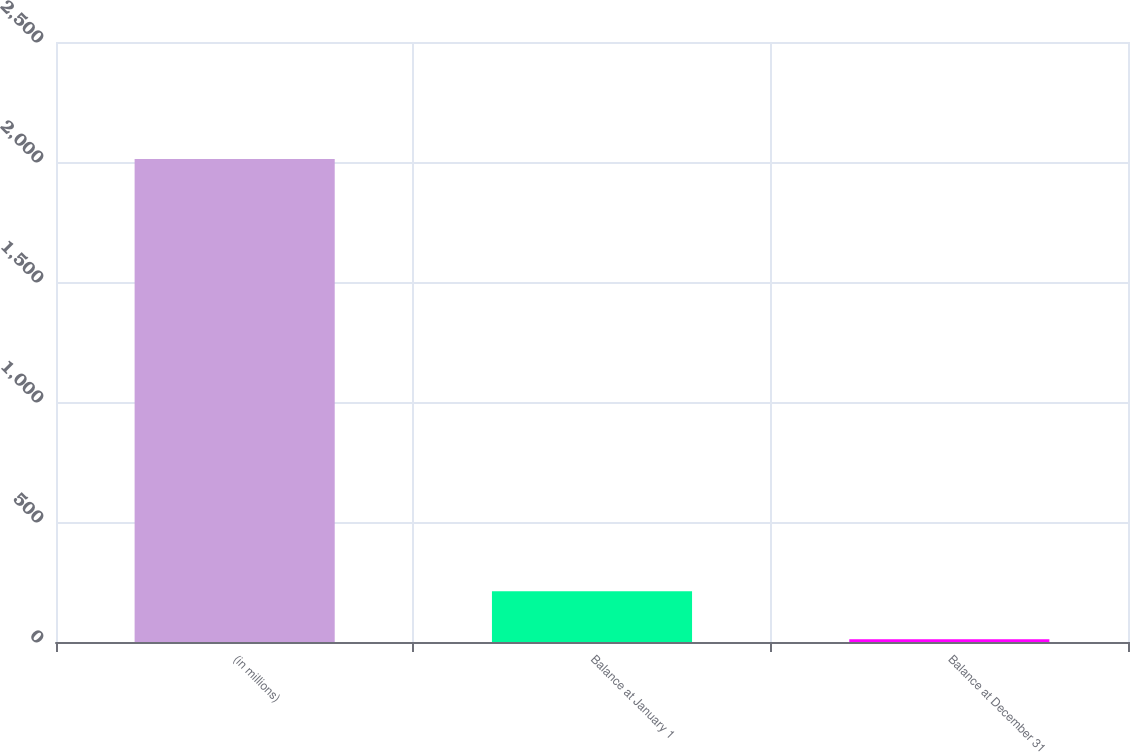Convert chart. <chart><loc_0><loc_0><loc_500><loc_500><bar_chart><fcel>(in millions)<fcel>Balance at January 1<fcel>Balance at December 31<nl><fcel>2013<fcel>211.2<fcel>11<nl></chart> 